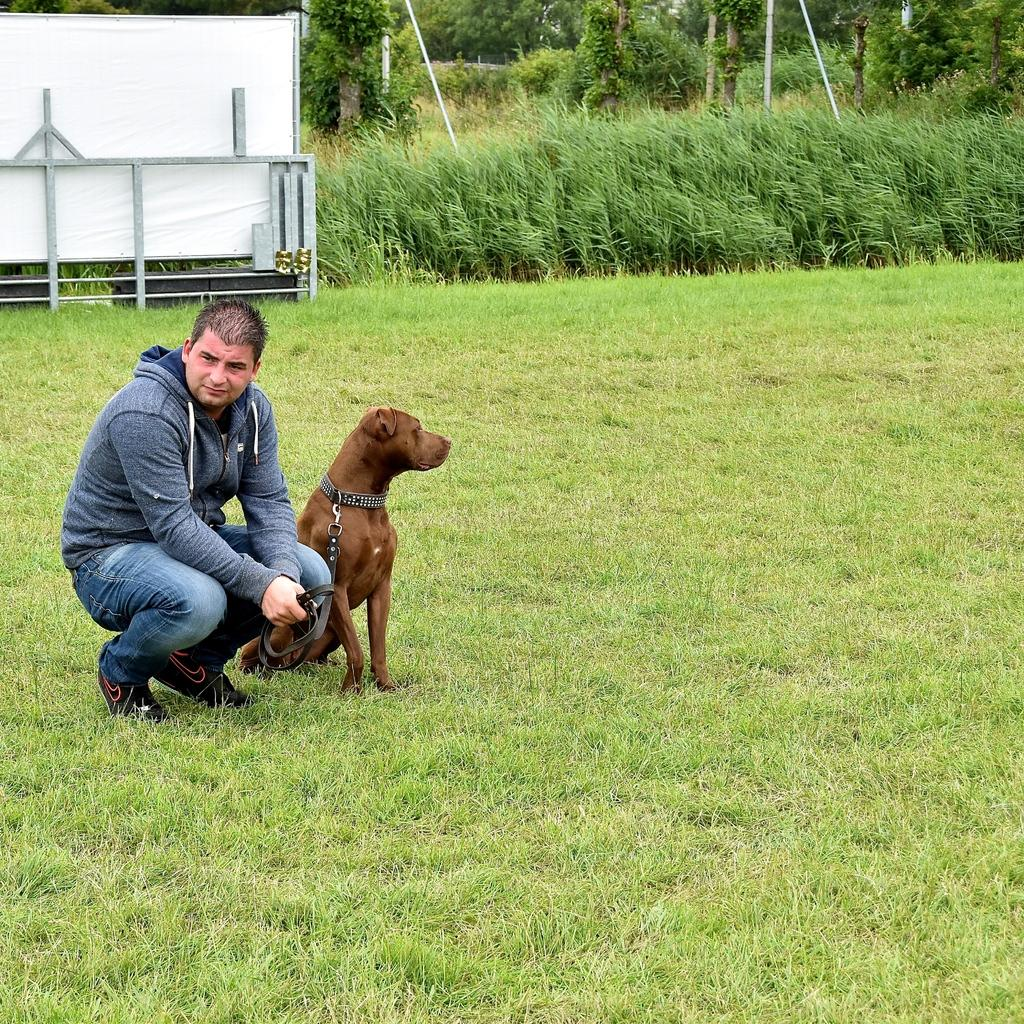What is the man's position in the image? There is a man on the ground in the image. What other living creature is present in the image? There is a dog in the image. What type of vegetation can be seen in the image? There are plants and trees visible in the image. What type of wine is the man drinking in the image? There is no wine present in the image; the man is on the ground, and there is a dog and vegetation visible. 